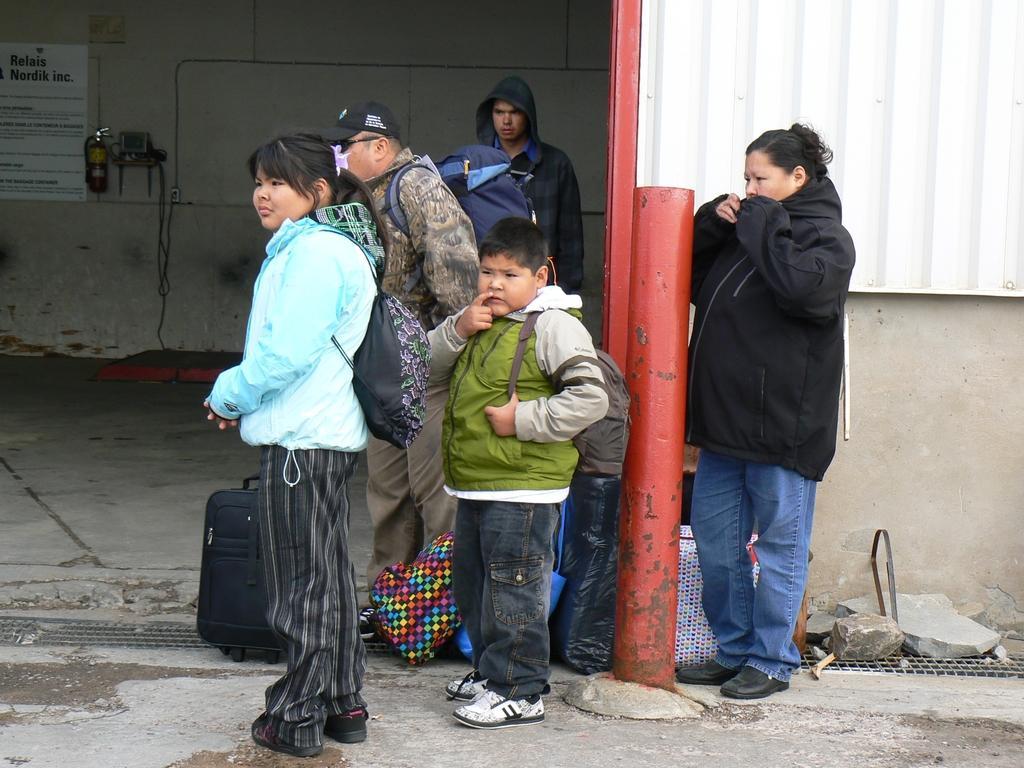How would you summarize this image in a sentence or two? In the center of the image we can see people standing. At the bottom there is a road and we can see luggage on the road. In the background there is a fire extinguisher and a board placed on the wall. In the background there is a shed. 